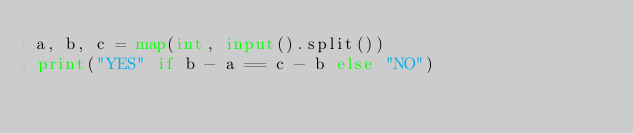<code> <loc_0><loc_0><loc_500><loc_500><_Python_>a, b, c = map(int, input().split())
print("YES" if b - a == c - b else "NO")</code> 